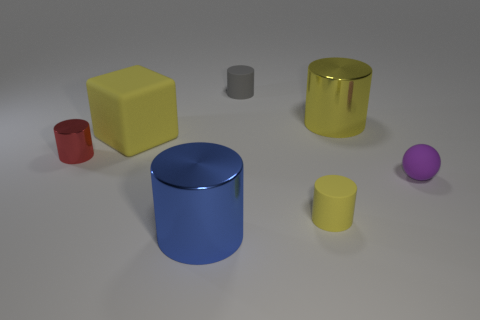What materials do the objects in the image seem to be made from? The objects in the image appear to have different finishes suggesting a variety of materials. The gold and blue cylinders have a metallic sheen, indicating they could be made of metal. The yellow and grey objects are matte, resembling plastic or painted surfaces, while the small red cup appears to have a ceramic or plastic finish. 